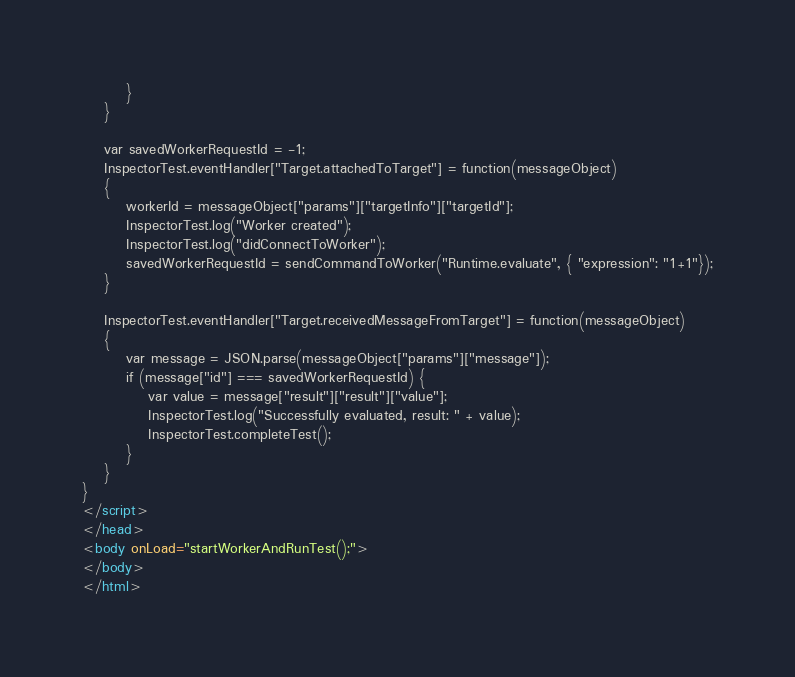Convert code to text. <code><loc_0><loc_0><loc_500><loc_500><_HTML_>        }
    }

    var savedWorkerRequestId = -1;
    InspectorTest.eventHandler["Target.attachedToTarget"] = function(messageObject)
    {
        workerId = messageObject["params"]["targetInfo"]["targetId"];
        InspectorTest.log("Worker created");
        InspectorTest.log("didConnectToWorker");
        savedWorkerRequestId = sendCommandToWorker("Runtime.evaluate", { "expression": "1+1"});
    }

    InspectorTest.eventHandler["Target.receivedMessageFromTarget"] = function(messageObject)
    {
        var message = JSON.parse(messageObject["params"]["message"]);
        if (message["id"] === savedWorkerRequestId) {
            var value = message["result"]["result"]["value"];
            InspectorTest.log("Successfully evaluated, result: " + value);
            InspectorTest.completeTest();
        }
    }
}
</script>
</head>
<body onLoad="startWorkerAndRunTest();">
</body>
</html>
</code> 